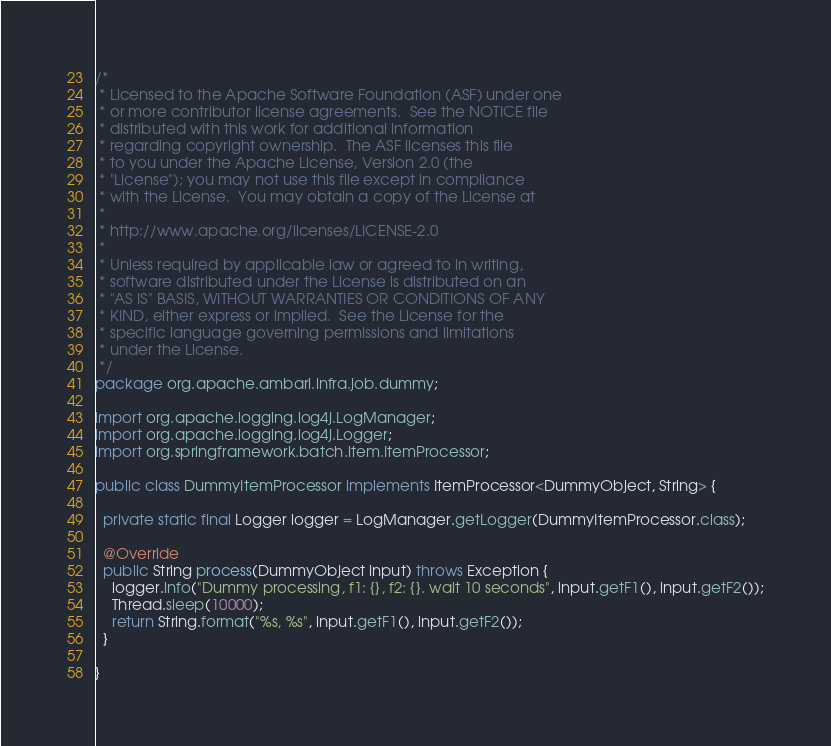Convert code to text. <code><loc_0><loc_0><loc_500><loc_500><_Java_>/*
 * Licensed to the Apache Software Foundation (ASF) under one
 * or more contributor license agreements.  See the NOTICE file
 * distributed with this work for additional information
 * regarding copyright ownership.  The ASF licenses this file
 * to you under the Apache License, Version 2.0 (the
 * "License"); you may not use this file except in compliance
 * with the License.  You may obtain a copy of the License at
 * 
 * http://www.apache.org/licenses/LICENSE-2.0
 * 
 * Unless required by applicable law or agreed to in writing,
 * software distributed under the License is distributed on an
 * "AS IS" BASIS, WITHOUT WARRANTIES OR CONDITIONS OF ANY
 * KIND, either express or implied.  See the License for the
 * specific language governing permissions and limitations
 * under the License.
 */
package org.apache.ambari.infra.job.dummy;

import org.apache.logging.log4j.LogManager;
import org.apache.logging.log4j.Logger;
import org.springframework.batch.item.ItemProcessor;

public class DummyItemProcessor implements ItemProcessor<DummyObject, String> {

  private static final Logger logger = LogManager.getLogger(DummyItemProcessor.class);

  @Override
  public String process(DummyObject input) throws Exception {
    logger.info("Dummy processing, f1: {}, f2: {}. wait 10 seconds", input.getF1(), input.getF2());
    Thread.sleep(10000);
    return String.format("%s, %s", input.getF1(), input.getF2());
  }

}
</code> 